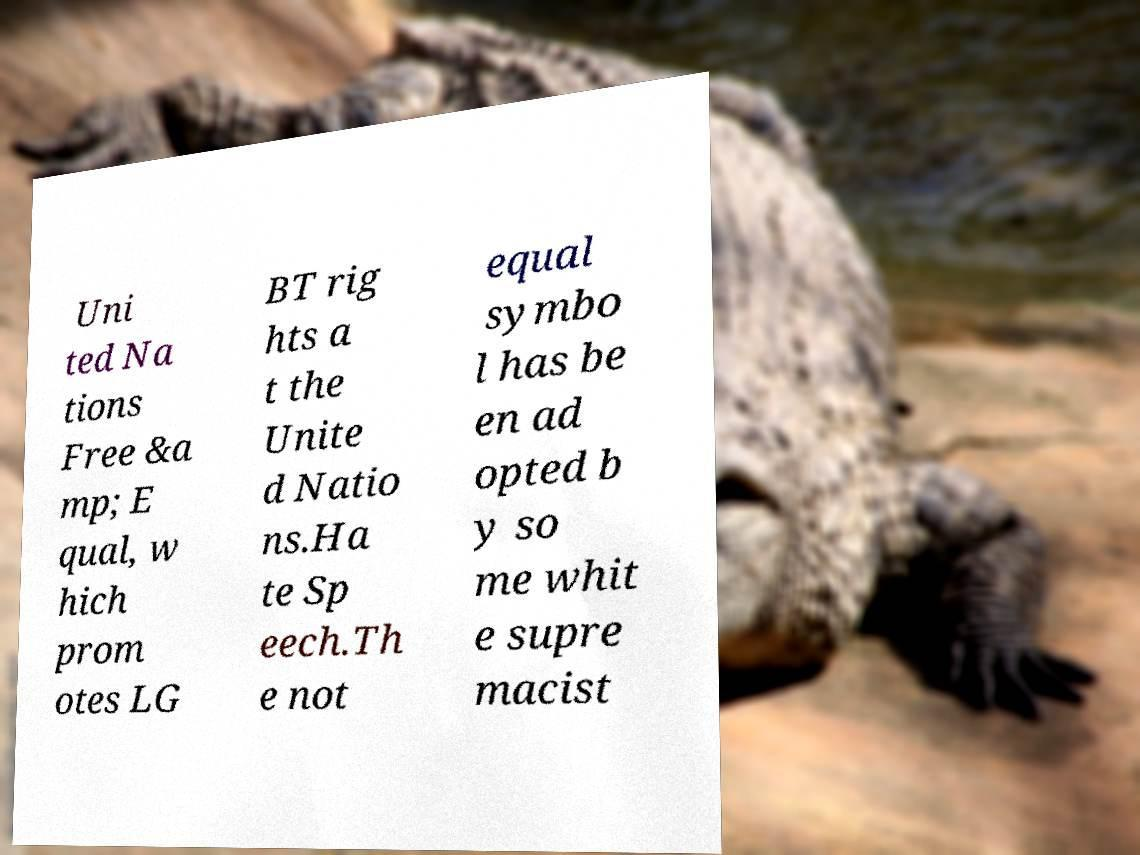Can you accurately transcribe the text from the provided image for me? Uni ted Na tions Free &a mp; E qual, w hich prom otes LG BT rig hts a t the Unite d Natio ns.Ha te Sp eech.Th e not equal symbo l has be en ad opted b y so me whit e supre macist 